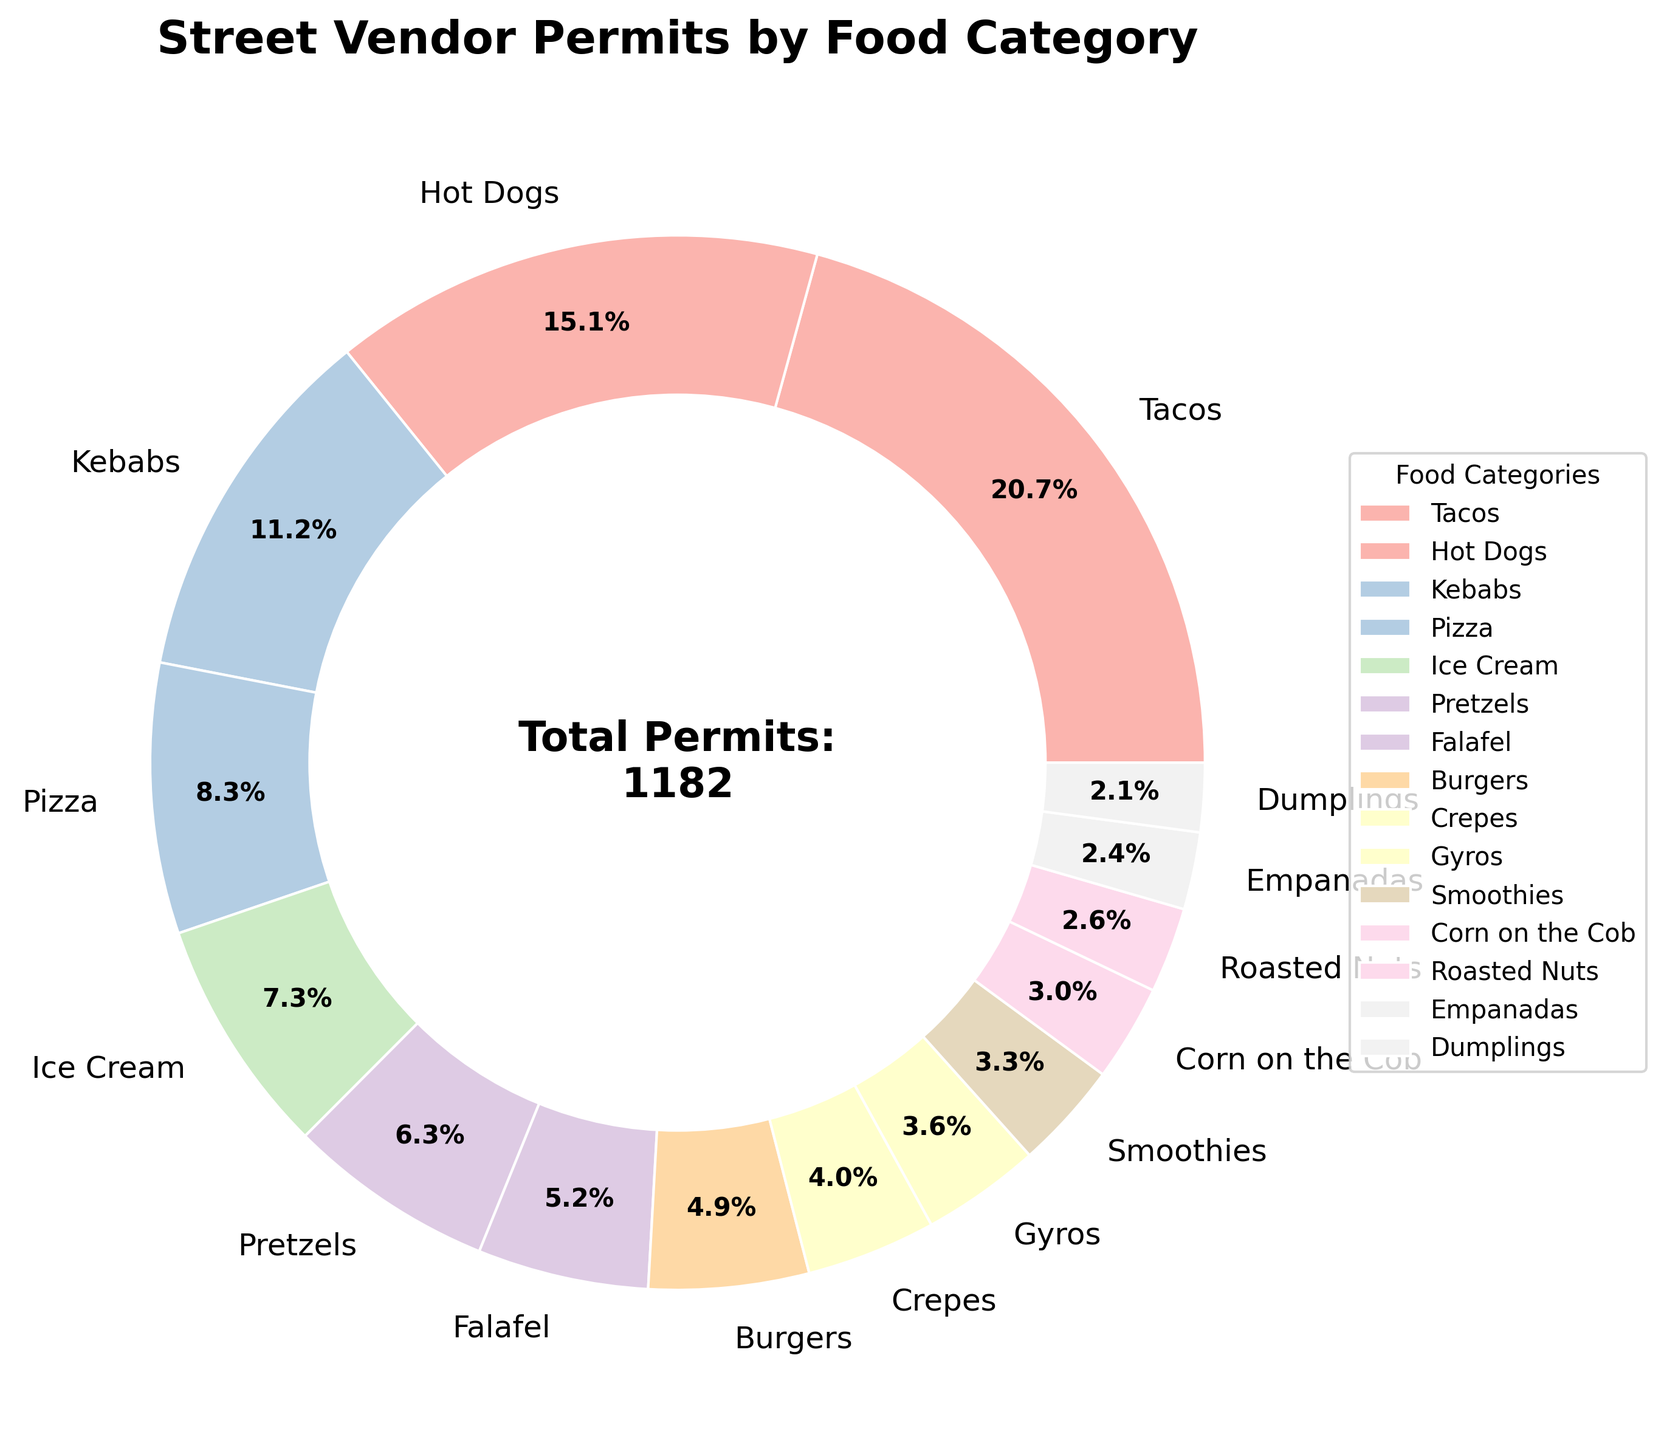How many more permits are issued for Tacos compared to Burgers? First, locate the segments for Tacos and Burgers in the pie chart. Tacos have 245 permits, and Burgers have 58 permits. Subtract the number of permits for Burgers from the number of permits for Tacos: 245 - 58 = 187
Answer: 187 What percentage of the permits is allocated to Pizza and Ice Cream combined? Add the permits issued for Pizza (98) and Ice Cream (86), resulting in 184 permits. The total number of permits is 1,182 (summed from all categories). Then, divide 184 by 1,182 and multiply by 100 to get the percentage: (184 / 1,182) * 100 ≈ 15.6%
Answer: ~15.6% Which food category has the smallest number of permits? Look for the smallest segment in the pie chart. The category with the fewest permits is Dumplings with 25 permits
Answer: Dumplings Are there more permits for Kebabs or for Crepes and Gyros combined? Count the permits for Kebabs (132), and then for Crepes (47) and Gyros (43) combined, which totals 90 permits. Compare 132 and 90 to see that Kebabs have more permits
Answer: Kebabs What's the total number of permits allocated for Hot Dogs, Ice Cream, and Pretzels together? Add the permits for Hot Dogs (178), Ice Cream (86), and Pretzels (75). The total is 178 + 86 + 75 = 339 permits
Answer: 339 Which category has a larger percentage: Falafel or Corn on the Cob? Compare the pie chart segments of Falafel and Corn on the Cob. Falafel has 62 permits, and Corn on the Cob has 35 permits. Calculate their percentages with respect to the total number of permits (1,182): Falafel - (62/1,182) * 100 ≈ 5.2%, Corn on the Cob - (35/1,182) * 100 ≈ 3%. Falafel has a larger percentage
Answer: Falafel What is the difference in permits between the highest category (Tacos) and the second highest category (Hot Dogs)? Identify the highest (Tacos, 245) and the second-highest (Hot Dogs, 178). Subtract the second highest from the highest: 245 - 178 = 67
Answer: 67 